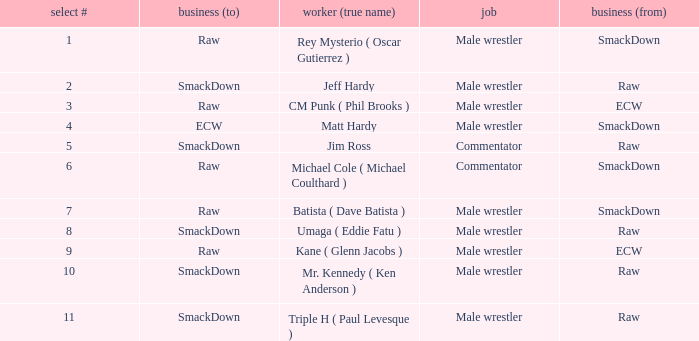What role did Pick # 10 have? Male wrestler. 